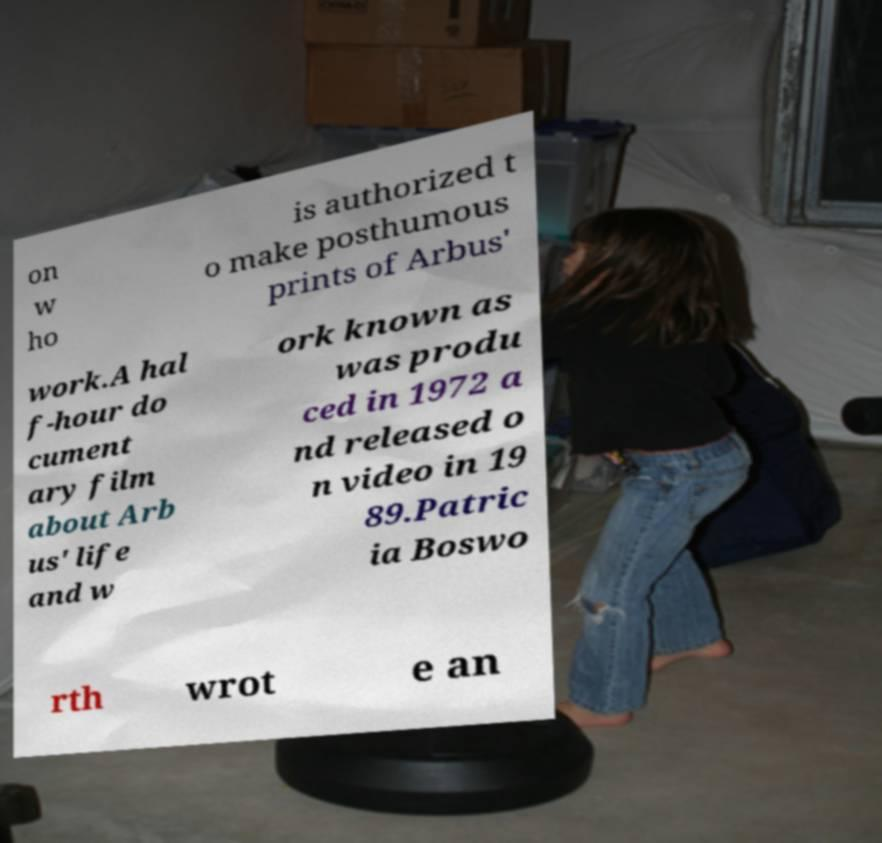Can you read and provide the text displayed in the image?This photo seems to have some interesting text. Can you extract and type it out for me? on w ho is authorized t o make posthumous prints of Arbus' work.A hal f-hour do cument ary film about Arb us' life and w ork known as was produ ced in 1972 a nd released o n video in 19 89.Patric ia Boswo rth wrot e an 